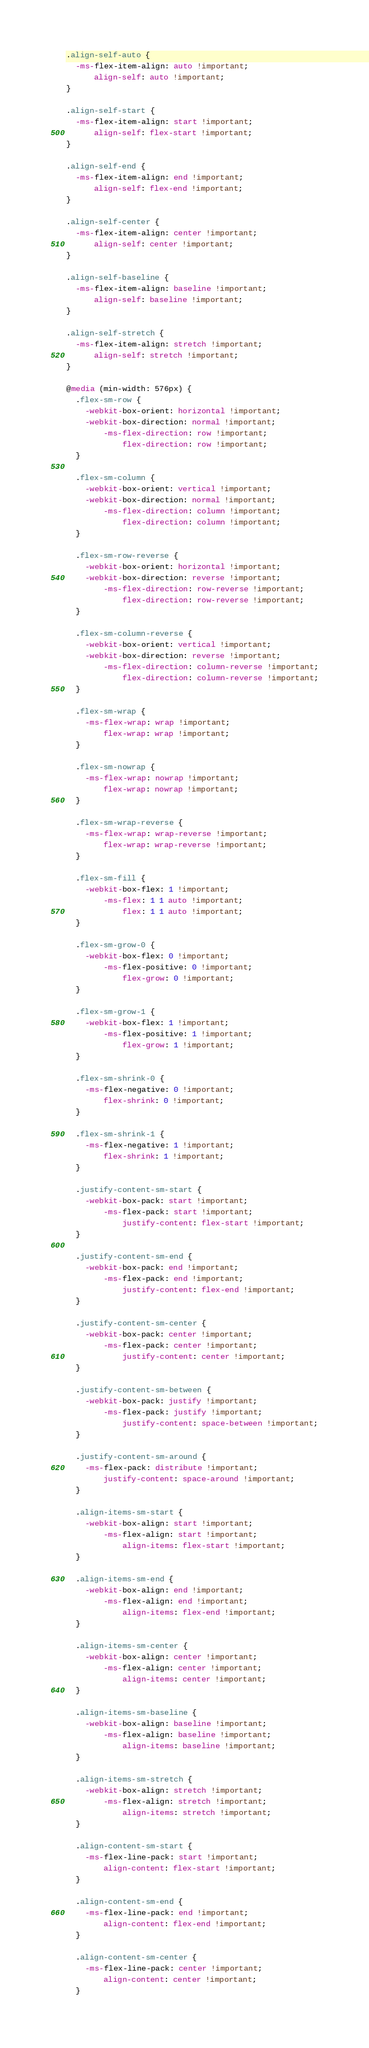Convert code to text. <code><loc_0><loc_0><loc_500><loc_500><_CSS_>
.align-self-auto {
  -ms-flex-item-align: auto !important;
      align-self: auto !important;
}

.align-self-start {
  -ms-flex-item-align: start !important;
      align-self: flex-start !important;
}

.align-self-end {
  -ms-flex-item-align: end !important;
      align-self: flex-end !important;
}

.align-self-center {
  -ms-flex-item-align: center !important;
      align-self: center !important;
}

.align-self-baseline {
  -ms-flex-item-align: baseline !important;
      align-self: baseline !important;
}

.align-self-stretch {
  -ms-flex-item-align: stretch !important;
      align-self: stretch !important;
}

@media (min-width: 576px) {
  .flex-sm-row {
    -webkit-box-orient: horizontal !important;
    -webkit-box-direction: normal !important;
        -ms-flex-direction: row !important;
            flex-direction: row !important;
  }

  .flex-sm-column {
    -webkit-box-orient: vertical !important;
    -webkit-box-direction: normal !important;
        -ms-flex-direction: column !important;
            flex-direction: column !important;
  }

  .flex-sm-row-reverse {
    -webkit-box-orient: horizontal !important;
    -webkit-box-direction: reverse !important;
        -ms-flex-direction: row-reverse !important;
            flex-direction: row-reverse !important;
  }

  .flex-sm-column-reverse {
    -webkit-box-orient: vertical !important;
    -webkit-box-direction: reverse !important;
        -ms-flex-direction: column-reverse !important;
            flex-direction: column-reverse !important;
  }

  .flex-sm-wrap {
    -ms-flex-wrap: wrap !important;
        flex-wrap: wrap !important;
  }

  .flex-sm-nowrap {
    -ms-flex-wrap: nowrap !important;
        flex-wrap: nowrap !important;
  }

  .flex-sm-wrap-reverse {
    -ms-flex-wrap: wrap-reverse !important;
        flex-wrap: wrap-reverse !important;
  }

  .flex-sm-fill {
    -webkit-box-flex: 1 !important;
        -ms-flex: 1 1 auto !important;
            flex: 1 1 auto !important;
  }

  .flex-sm-grow-0 {
    -webkit-box-flex: 0 !important;
        -ms-flex-positive: 0 !important;
            flex-grow: 0 !important;
  }

  .flex-sm-grow-1 {
    -webkit-box-flex: 1 !important;
        -ms-flex-positive: 1 !important;
            flex-grow: 1 !important;
  }

  .flex-sm-shrink-0 {
    -ms-flex-negative: 0 !important;
        flex-shrink: 0 !important;
  }

  .flex-sm-shrink-1 {
    -ms-flex-negative: 1 !important;
        flex-shrink: 1 !important;
  }

  .justify-content-sm-start {
    -webkit-box-pack: start !important;
        -ms-flex-pack: start !important;
            justify-content: flex-start !important;
  }

  .justify-content-sm-end {
    -webkit-box-pack: end !important;
        -ms-flex-pack: end !important;
            justify-content: flex-end !important;
  }

  .justify-content-sm-center {
    -webkit-box-pack: center !important;
        -ms-flex-pack: center !important;
            justify-content: center !important;
  }

  .justify-content-sm-between {
    -webkit-box-pack: justify !important;
        -ms-flex-pack: justify !important;
            justify-content: space-between !important;
  }

  .justify-content-sm-around {
    -ms-flex-pack: distribute !important;
        justify-content: space-around !important;
  }

  .align-items-sm-start {
    -webkit-box-align: start !important;
        -ms-flex-align: start !important;
            align-items: flex-start !important;
  }

  .align-items-sm-end {
    -webkit-box-align: end !important;
        -ms-flex-align: end !important;
            align-items: flex-end !important;
  }

  .align-items-sm-center {
    -webkit-box-align: center !important;
        -ms-flex-align: center !important;
            align-items: center !important;
  }

  .align-items-sm-baseline {
    -webkit-box-align: baseline !important;
        -ms-flex-align: baseline !important;
            align-items: baseline !important;
  }

  .align-items-sm-stretch {
    -webkit-box-align: stretch !important;
        -ms-flex-align: stretch !important;
            align-items: stretch !important;
  }

  .align-content-sm-start {
    -ms-flex-line-pack: start !important;
        align-content: flex-start !important;
  }

  .align-content-sm-end {
    -ms-flex-line-pack: end !important;
        align-content: flex-end !important;
  }

  .align-content-sm-center {
    -ms-flex-line-pack: center !important;
        align-content: center !important;
  }
</code> 